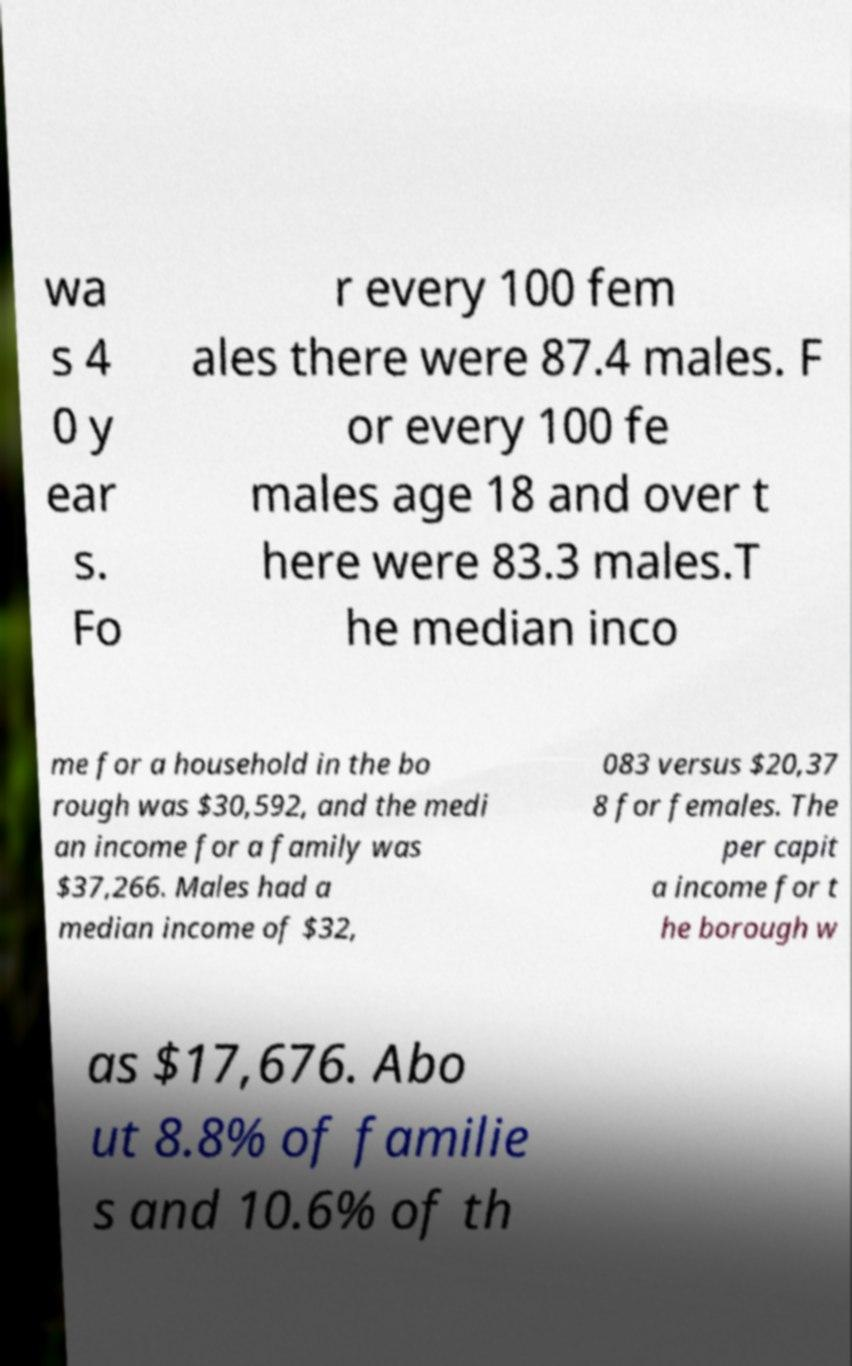Could you assist in decoding the text presented in this image and type it out clearly? wa s 4 0 y ear s. Fo r every 100 fem ales there were 87.4 males. F or every 100 fe males age 18 and over t here were 83.3 males.T he median inco me for a household in the bo rough was $30,592, and the medi an income for a family was $37,266. Males had a median income of $32, 083 versus $20,37 8 for females. The per capit a income for t he borough w as $17,676. Abo ut 8.8% of familie s and 10.6% of th 